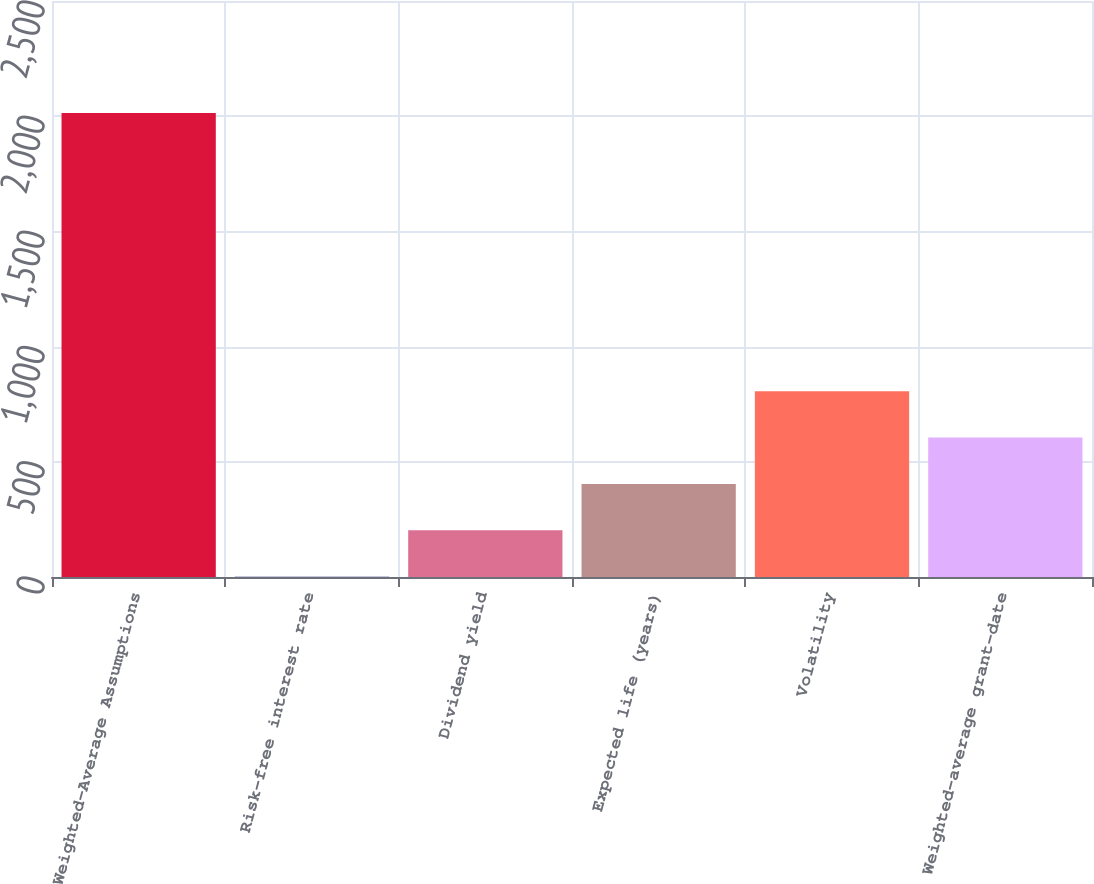Convert chart. <chart><loc_0><loc_0><loc_500><loc_500><bar_chart><fcel>Weighted-Average Assumptions<fcel>Risk-free interest rate<fcel>Dividend yield<fcel>Expected life (years)<fcel>Volatility<fcel>Weighted-average grant-date<nl><fcel>2014<fcel>1.6<fcel>202.84<fcel>404.08<fcel>806.56<fcel>605.32<nl></chart> 